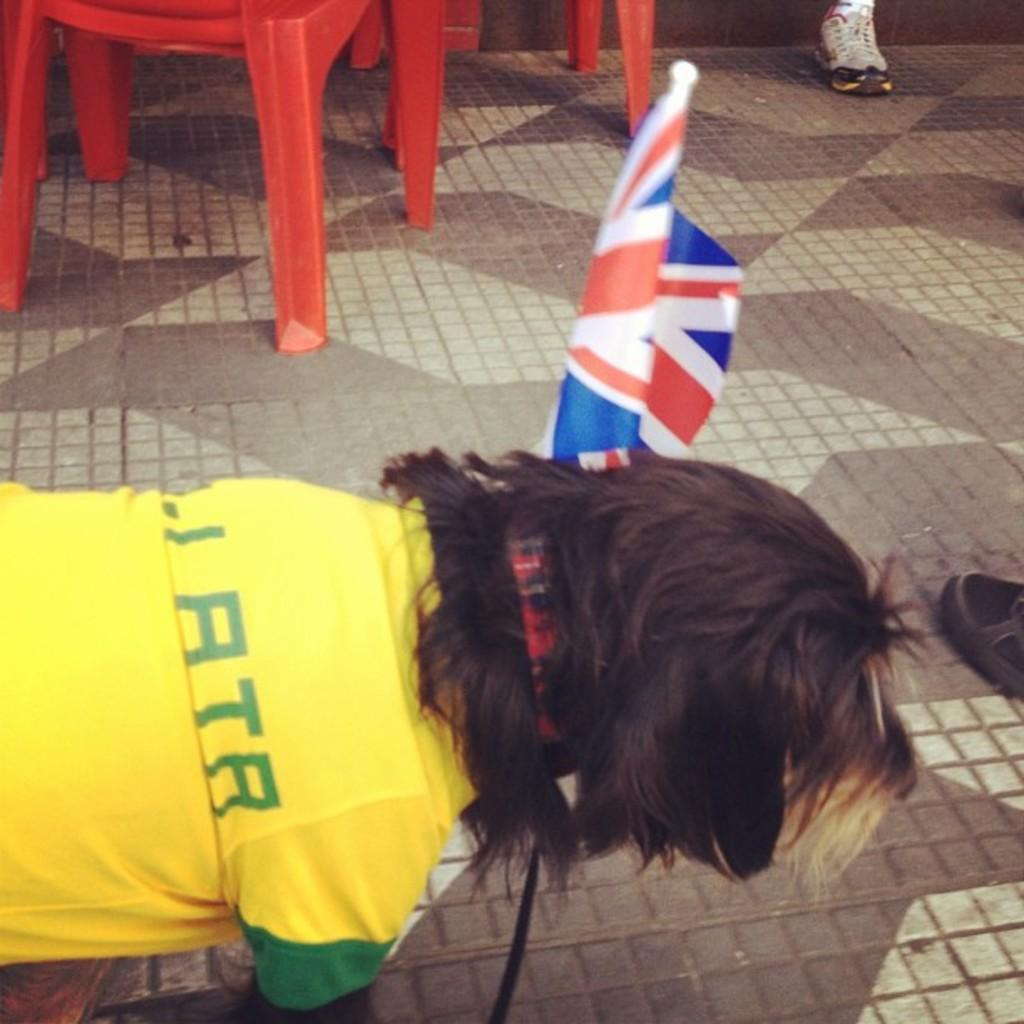What type of animal is present in the image? There is a dog in the image. What is the dog wearing? The dog is wearing a shirt. What other object can be seen in the image? There is a flag in the image. What part of a person can be seen in the image? A person's shoes are visible in the image. Where are the chairs located in the image? The chairs are on a path in the image. What type of doctor is present in the image? There is no doctor present in the image; it features a dog wearing a shirt, a flag, shoes, and chairs on a path. Is the shirt in the image hot or cold? The fact does not mention the temperature of the shirt, so it cannot be determined from the image. 